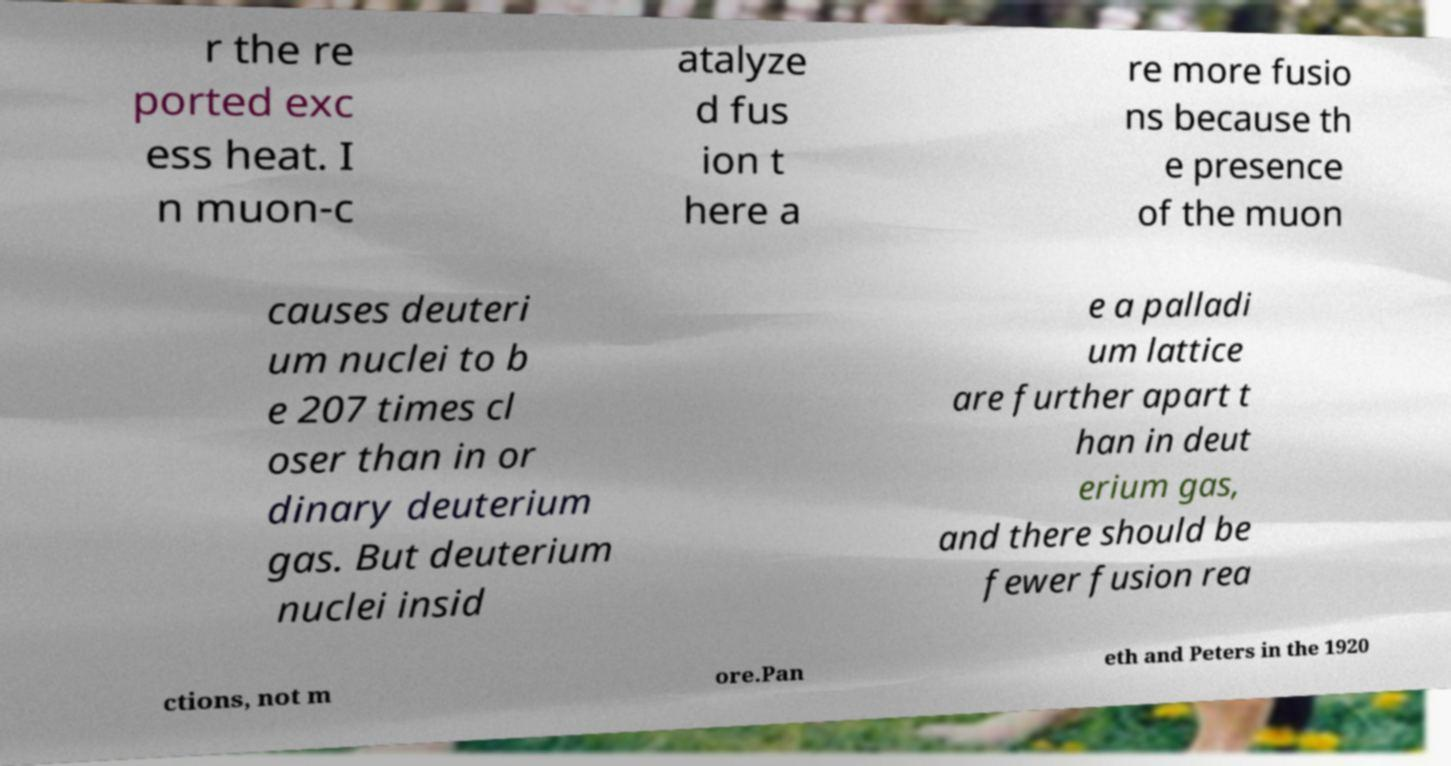Please identify and transcribe the text found in this image. r the re ported exc ess heat. I n muon-c atalyze d fus ion t here a re more fusio ns because th e presence of the muon causes deuteri um nuclei to b e 207 times cl oser than in or dinary deuterium gas. But deuterium nuclei insid e a palladi um lattice are further apart t han in deut erium gas, and there should be fewer fusion rea ctions, not m ore.Pan eth and Peters in the 1920 